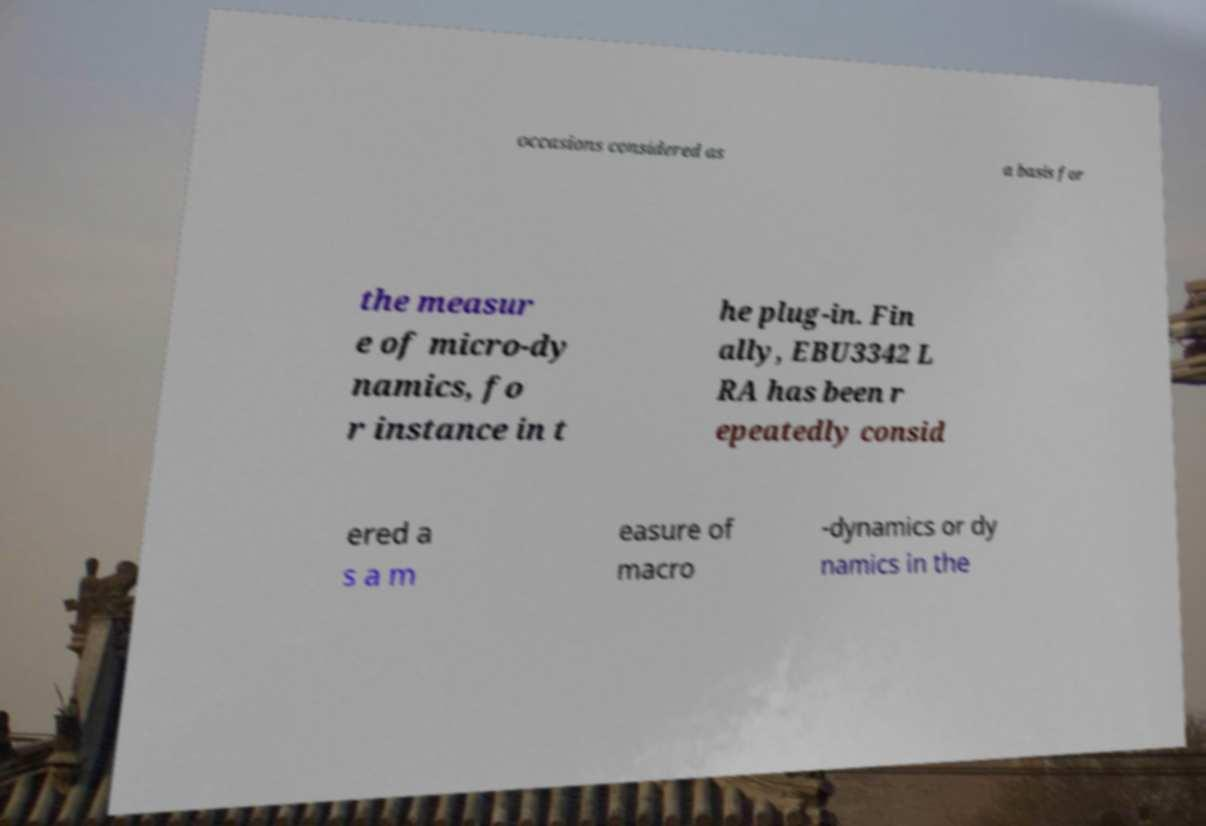Could you assist in decoding the text presented in this image and type it out clearly? occasions considered as a basis for the measur e of micro-dy namics, fo r instance in t he plug-in. Fin ally, EBU3342 L RA has been r epeatedly consid ered a s a m easure of macro -dynamics or dy namics in the 